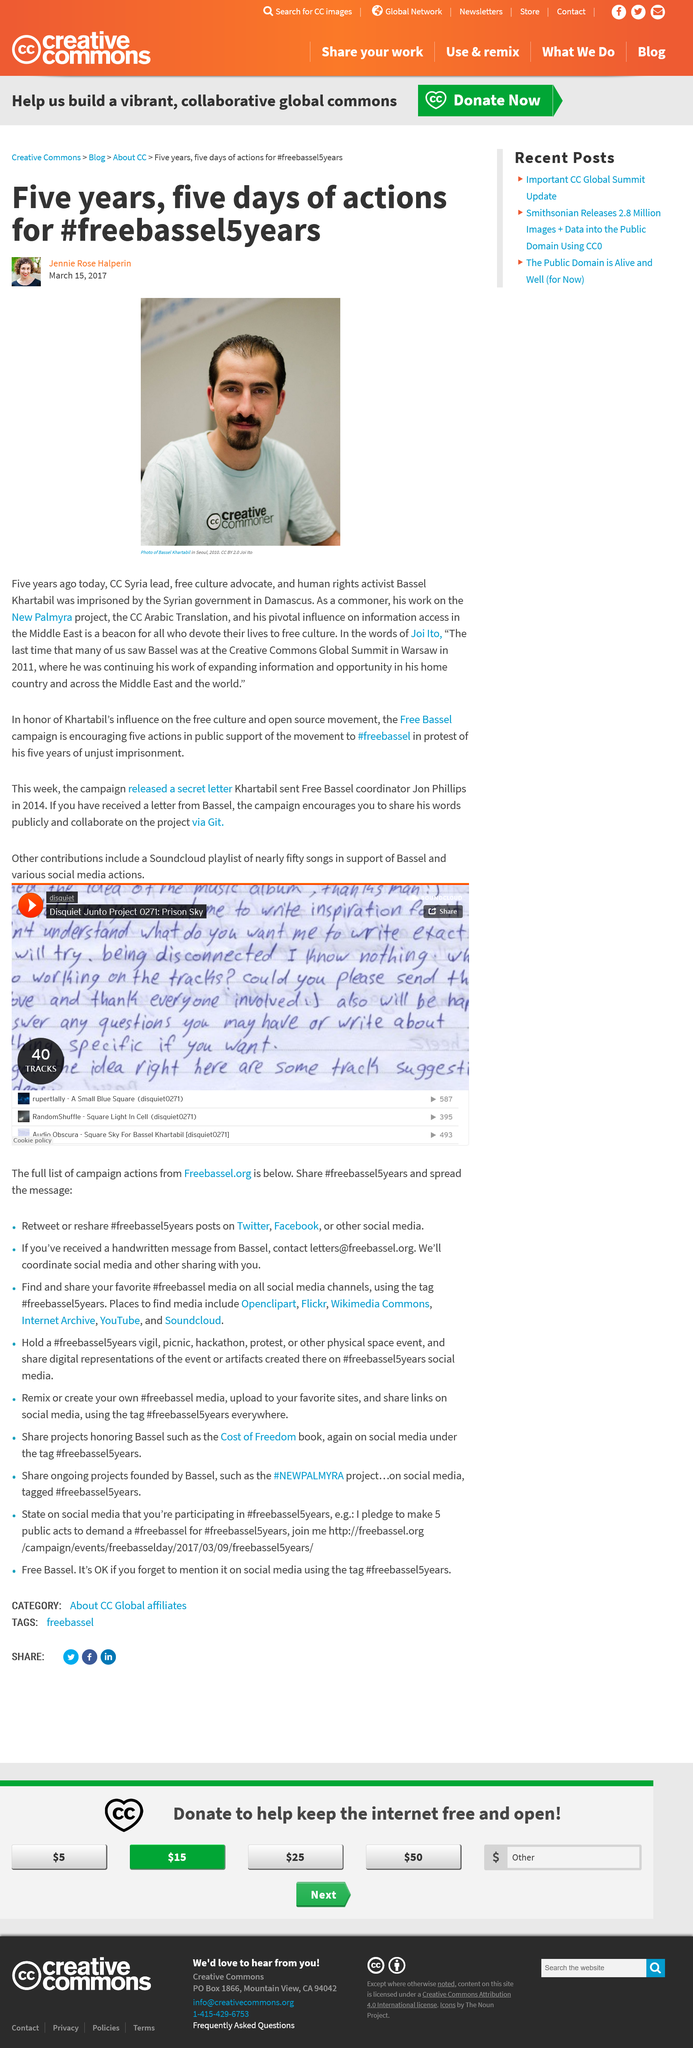Identify some key points in this picture. He was last seen at the CC Global Summit 2011 in Warsaw. Bassel Khartabil, who is pictured in the photo, is featured in a photo that is a photo of Bassel Khartabil. Bassel was imprisoned due to what happened to him. 